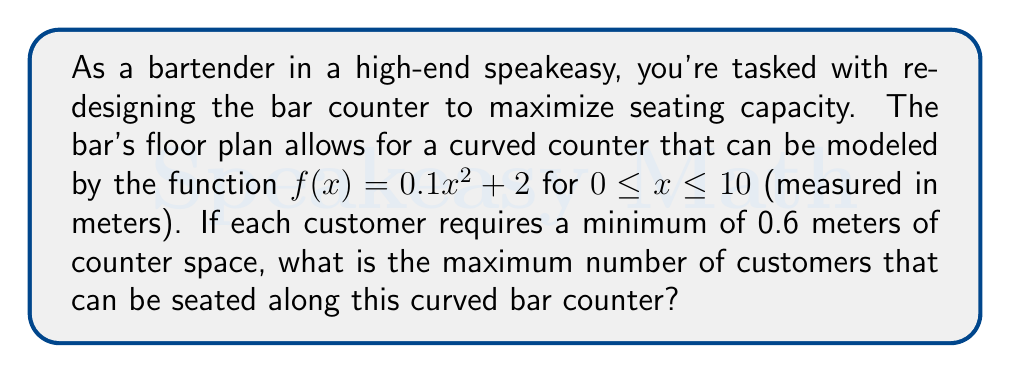Can you solve this math problem? To solve this problem, we need to calculate the arc length of the curved bar counter and then divide it by the space required for each customer. Let's break it down step-by-step:

1) The arc length formula for a curve $y = f(x)$ from $a$ to $b$ is:

   $$L = \int_a^b \sqrt{1 + [f'(x)]^2} dx$$

2) First, we need to find $f'(x)$:
   
   $f(x) = 0.1x^2 + 2$
   $f'(x) = 0.2x$

3) Now we can set up our integral:

   $$L = \int_0^{10} \sqrt{1 + (0.2x)^2} dx$$

4) This integral is difficult to solve analytically, so we'll use numerical integration. Using a calculator or computer software, we can approximate this integral:

   $$L \approx 10.4954 \text{ meters}$$

5) Now that we have the length of the bar, we can divide it by the space required per customer:

   $\text{Number of customers} = \frac{\text{Total length}}{\text{Space per customer}} = \frac{10.4954}{0.6}$

6) Since we can't seat a fraction of a person, we need to round down to the nearest whole number.

[asy]
size(200,100);
real f(real x) {return 0.1*x^2 + 2;}
draw(graph(f,0,10),blue);
draw((0,0)--(10,0),arrow=Arrow(TeXHead));
draw((0,0)--(0,12),arrow=Arrow(TeXHead));
label("x",
(10,0),SE);
label("y",(0,12),NW);
[/asy]
Answer: The maximum number of customers that can be seated along the curved bar counter is 17. 